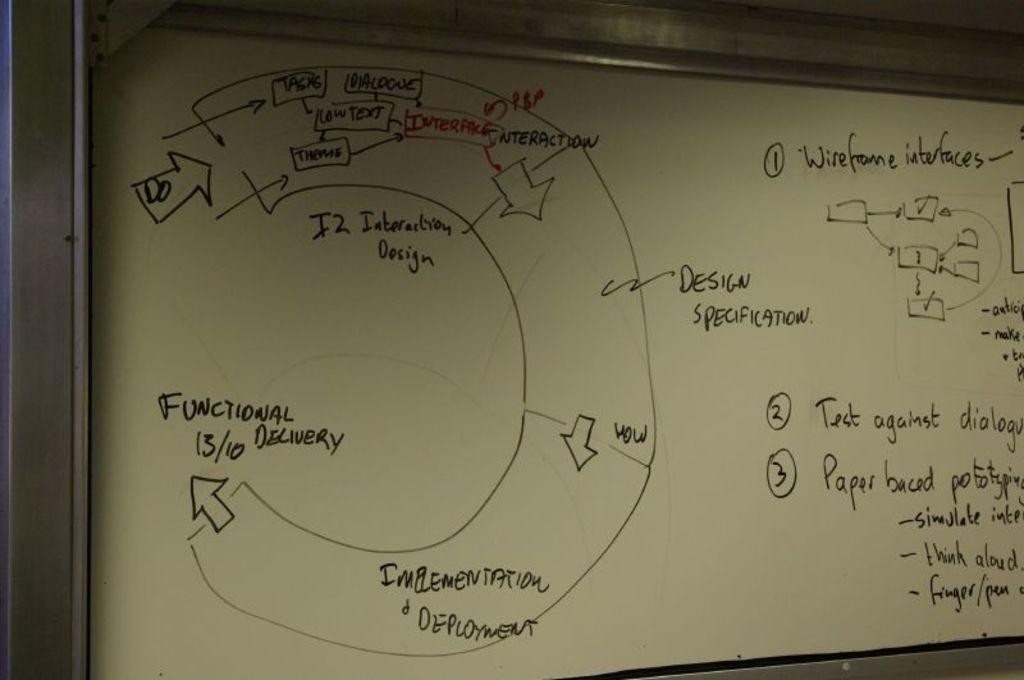<image>
Present a compact description of the photo's key features. A white board has words written on it including functional delivery. 